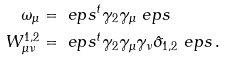Convert formula to latex. <formula><loc_0><loc_0><loc_500><loc_500>\omega _ { \mu } & = \ e p s ^ { t } \gamma _ { 2 } \gamma _ { \mu } \ e p s \\ W ^ { 1 , 2 } _ { \mu \nu } & = \ e p s ^ { t } \gamma _ { 2 } \gamma _ { \mu } \gamma _ { \nu } \hat { \sigma } _ { 1 , 2 } \ e p s \, .</formula> 